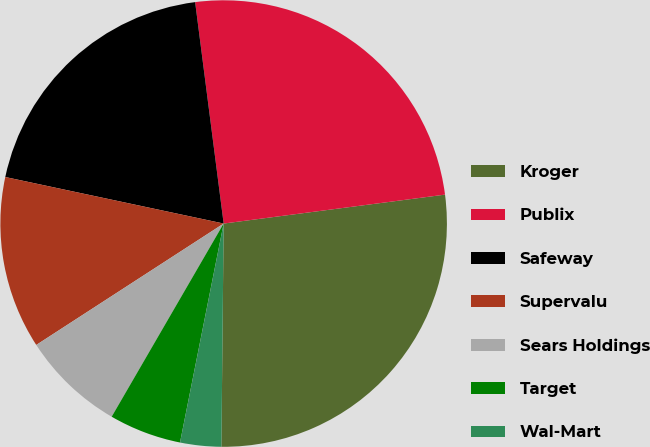Convert chart. <chart><loc_0><loc_0><loc_500><loc_500><pie_chart><fcel>Kroger<fcel>Publix<fcel>Safeway<fcel>Supervalu<fcel>Sears Holdings<fcel>Target<fcel>Wal-Mart<nl><fcel>27.23%<fcel>24.97%<fcel>19.62%<fcel>12.49%<fcel>7.49%<fcel>5.23%<fcel>2.97%<nl></chart> 